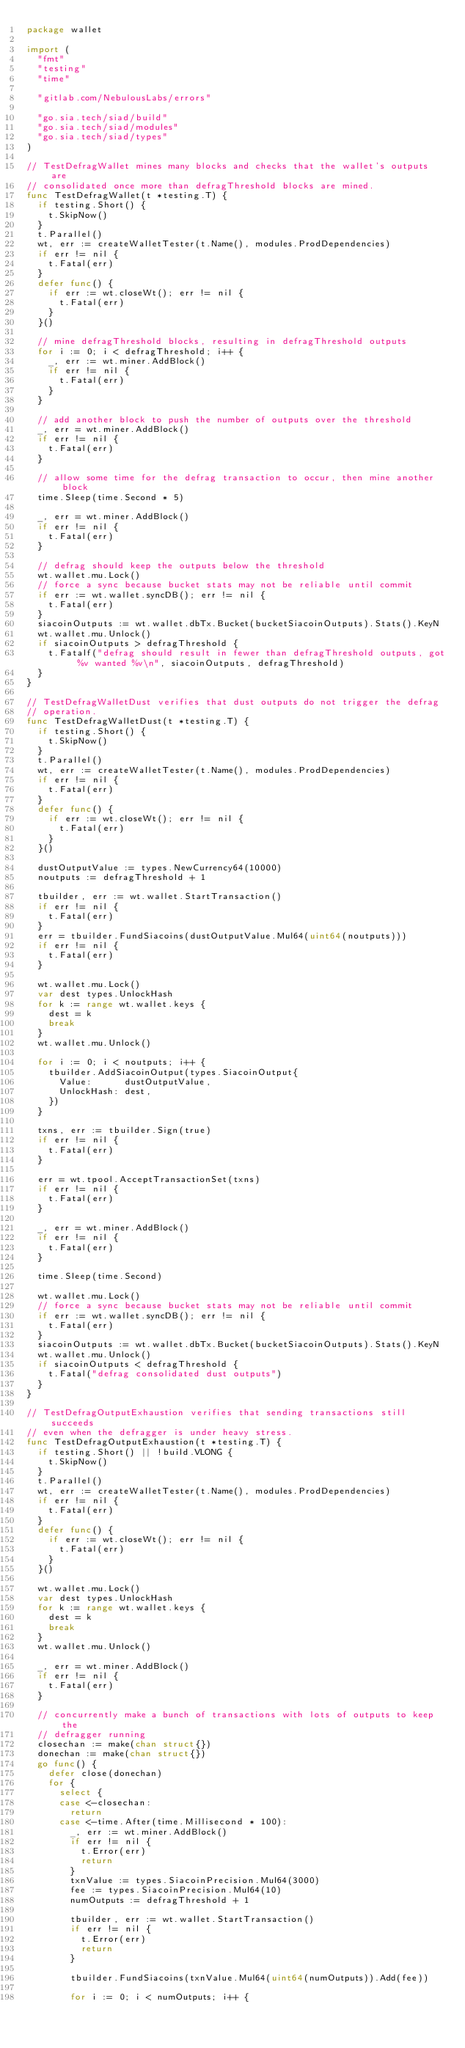<code> <loc_0><loc_0><loc_500><loc_500><_Go_>package wallet

import (
	"fmt"
	"testing"
	"time"

	"gitlab.com/NebulousLabs/errors"

	"go.sia.tech/siad/build"
	"go.sia.tech/siad/modules"
	"go.sia.tech/siad/types"
)

// TestDefragWallet mines many blocks and checks that the wallet's outputs are
// consolidated once more than defragThreshold blocks are mined.
func TestDefragWallet(t *testing.T) {
	if testing.Short() {
		t.SkipNow()
	}
	t.Parallel()
	wt, err := createWalletTester(t.Name(), modules.ProdDependencies)
	if err != nil {
		t.Fatal(err)
	}
	defer func() {
		if err := wt.closeWt(); err != nil {
			t.Fatal(err)
		}
	}()

	// mine defragThreshold blocks, resulting in defragThreshold outputs
	for i := 0; i < defragThreshold; i++ {
		_, err := wt.miner.AddBlock()
		if err != nil {
			t.Fatal(err)
		}
	}

	// add another block to push the number of outputs over the threshold
	_, err = wt.miner.AddBlock()
	if err != nil {
		t.Fatal(err)
	}

	// allow some time for the defrag transaction to occur, then mine another block
	time.Sleep(time.Second * 5)

	_, err = wt.miner.AddBlock()
	if err != nil {
		t.Fatal(err)
	}

	// defrag should keep the outputs below the threshold
	wt.wallet.mu.Lock()
	// force a sync because bucket stats may not be reliable until commit
	if err := wt.wallet.syncDB(); err != nil {
		t.Fatal(err)
	}
	siacoinOutputs := wt.wallet.dbTx.Bucket(bucketSiacoinOutputs).Stats().KeyN
	wt.wallet.mu.Unlock()
	if siacoinOutputs > defragThreshold {
		t.Fatalf("defrag should result in fewer than defragThreshold outputs, got %v wanted %v\n", siacoinOutputs, defragThreshold)
	}
}

// TestDefragWalletDust verifies that dust outputs do not trigger the defrag
// operation.
func TestDefragWalletDust(t *testing.T) {
	if testing.Short() {
		t.SkipNow()
	}
	t.Parallel()
	wt, err := createWalletTester(t.Name(), modules.ProdDependencies)
	if err != nil {
		t.Fatal(err)
	}
	defer func() {
		if err := wt.closeWt(); err != nil {
			t.Fatal(err)
		}
	}()

	dustOutputValue := types.NewCurrency64(10000)
	noutputs := defragThreshold + 1

	tbuilder, err := wt.wallet.StartTransaction()
	if err != nil {
		t.Fatal(err)
	}
	err = tbuilder.FundSiacoins(dustOutputValue.Mul64(uint64(noutputs)))
	if err != nil {
		t.Fatal(err)
	}

	wt.wallet.mu.Lock()
	var dest types.UnlockHash
	for k := range wt.wallet.keys {
		dest = k
		break
	}
	wt.wallet.mu.Unlock()

	for i := 0; i < noutputs; i++ {
		tbuilder.AddSiacoinOutput(types.SiacoinOutput{
			Value:      dustOutputValue,
			UnlockHash: dest,
		})
	}

	txns, err := tbuilder.Sign(true)
	if err != nil {
		t.Fatal(err)
	}

	err = wt.tpool.AcceptTransactionSet(txns)
	if err != nil {
		t.Fatal(err)
	}

	_, err = wt.miner.AddBlock()
	if err != nil {
		t.Fatal(err)
	}

	time.Sleep(time.Second)

	wt.wallet.mu.Lock()
	// force a sync because bucket stats may not be reliable until commit
	if err := wt.wallet.syncDB(); err != nil {
		t.Fatal(err)
	}
	siacoinOutputs := wt.wallet.dbTx.Bucket(bucketSiacoinOutputs).Stats().KeyN
	wt.wallet.mu.Unlock()
	if siacoinOutputs < defragThreshold {
		t.Fatal("defrag consolidated dust outputs")
	}
}

// TestDefragOutputExhaustion verifies that sending transactions still succeeds
// even when the defragger is under heavy stress.
func TestDefragOutputExhaustion(t *testing.T) {
	if testing.Short() || !build.VLONG {
		t.SkipNow()
	}
	t.Parallel()
	wt, err := createWalletTester(t.Name(), modules.ProdDependencies)
	if err != nil {
		t.Fatal(err)
	}
	defer func() {
		if err := wt.closeWt(); err != nil {
			t.Fatal(err)
		}
	}()

	wt.wallet.mu.Lock()
	var dest types.UnlockHash
	for k := range wt.wallet.keys {
		dest = k
		break
	}
	wt.wallet.mu.Unlock()

	_, err = wt.miner.AddBlock()
	if err != nil {
		t.Fatal(err)
	}

	// concurrently make a bunch of transactions with lots of outputs to keep the
	// defragger running
	closechan := make(chan struct{})
	donechan := make(chan struct{})
	go func() {
		defer close(donechan)
		for {
			select {
			case <-closechan:
				return
			case <-time.After(time.Millisecond * 100):
				_, err := wt.miner.AddBlock()
				if err != nil {
					t.Error(err)
					return
				}
				txnValue := types.SiacoinPrecision.Mul64(3000)
				fee := types.SiacoinPrecision.Mul64(10)
				numOutputs := defragThreshold + 1

				tbuilder, err := wt.wallet.StartTransaction()
				if err != nil {
					t.Error(err)
					return
				}

				tbuilder.FundSiacoins(txnValue.Mul64(uint64(numOutputs)).Add(fee))

				for i := 0; i < numOutputs; i++ {</code> 